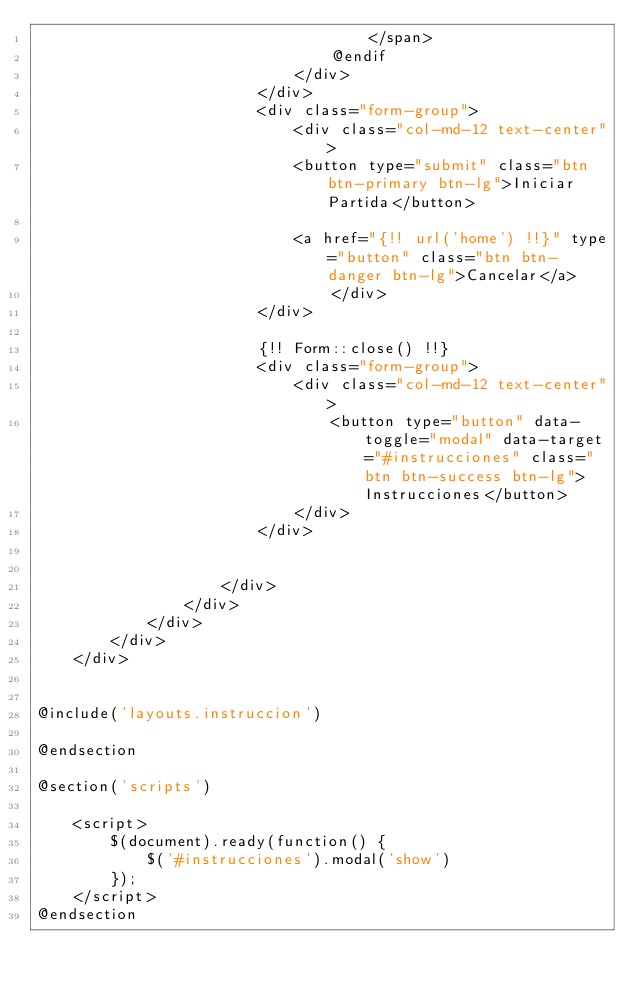Convert code to text. <code><loc_0><loc_0><loc_500><loc_500><_PHP_>                                    </span>
                                @endif
                            </div>
                        </div>
                        <div class="form-group">
                            <div class="col-md-12 text-center">
                            <button type="submit" class="btn btn-primary btn-lg">Iniciar Partida</button>

                            <a href="{!! url('home') !!}" type="button" class="btn btn-danger btn-lg">Cancelar</a>
                                </div>
                        </div>

                        {!! Form::close() !!}
                        <div class="form-group">
                            <div class="col-md-12 text-center">
                                <button type="button" data-toggle="modal" data-target="#instrucciones" class="btn btn-success btn-lg">Instrucciones</button>
                            </div>
                        </div>


                    </div>
                </div>
            </div>
        </div>
    </div>


@include('layouts.instruccion')

@endsection

@section('scripts')

    <script>
        $(document).ready(function() {
            $('#instrucciones').modal('show')
        });
    </script>
@endsection</code> 